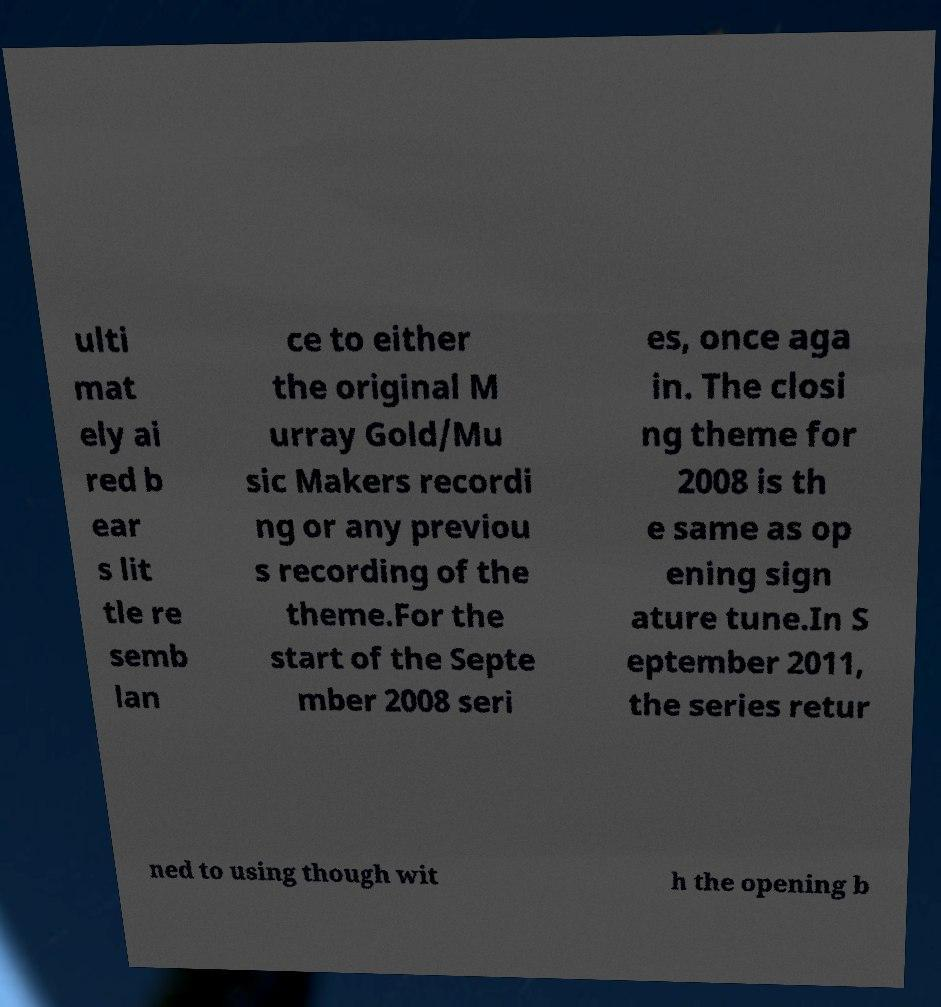Could you extract and type out the text from this image? ulti mat ely ai red b ear s lit tle re semb lan ce to either the original M urray Gold/Mu sic Makers recordi ng or any previou s recording of the theme.For the start of the Septe mber 2008 seri es, once aga in. The closi ng theme for 2008 is th e same as op ening sign ature tune.In S eptember 2011, the series retur ned to using though wit h the opening b 